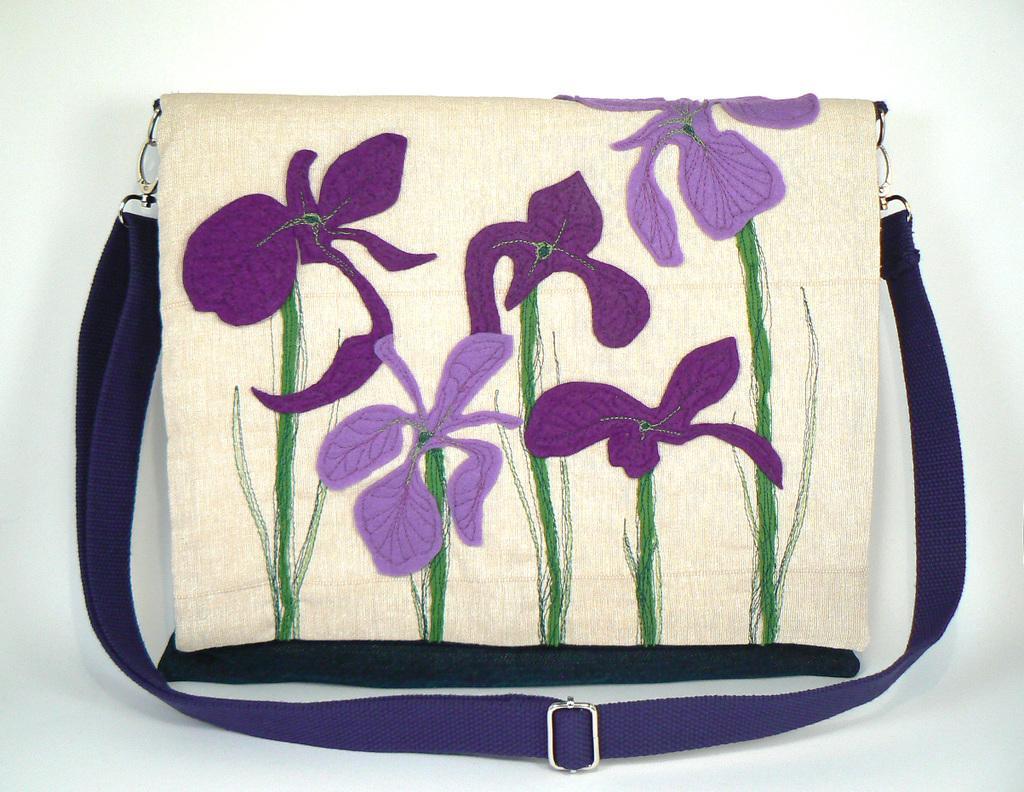Describe this image in one or two sentences. In this picture we can see a bag. On this bag we can see a thread work of flowers. 